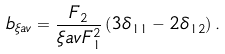<formula> <loc_0><loc_0><loc_500><loc_500>b _ { \xi a v } = \frac { F _ { 2 } } { \xi a v F _ { 1 } ^ { 2 } } \left ( 3 \delta _ { 1 1 } - 2 \delta _ { 1 2 } \right ) .</formula> 